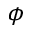Convert formula to latex. <formula><loc_0><loc_0><loc_500><loc_500>\phi</formula> 